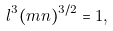<formula> <loc_0><loc_0><loc_500><loc_500>l ^ { 3 } ( m n ) ^ { 3 / 2 } = 1 ,</formula> 